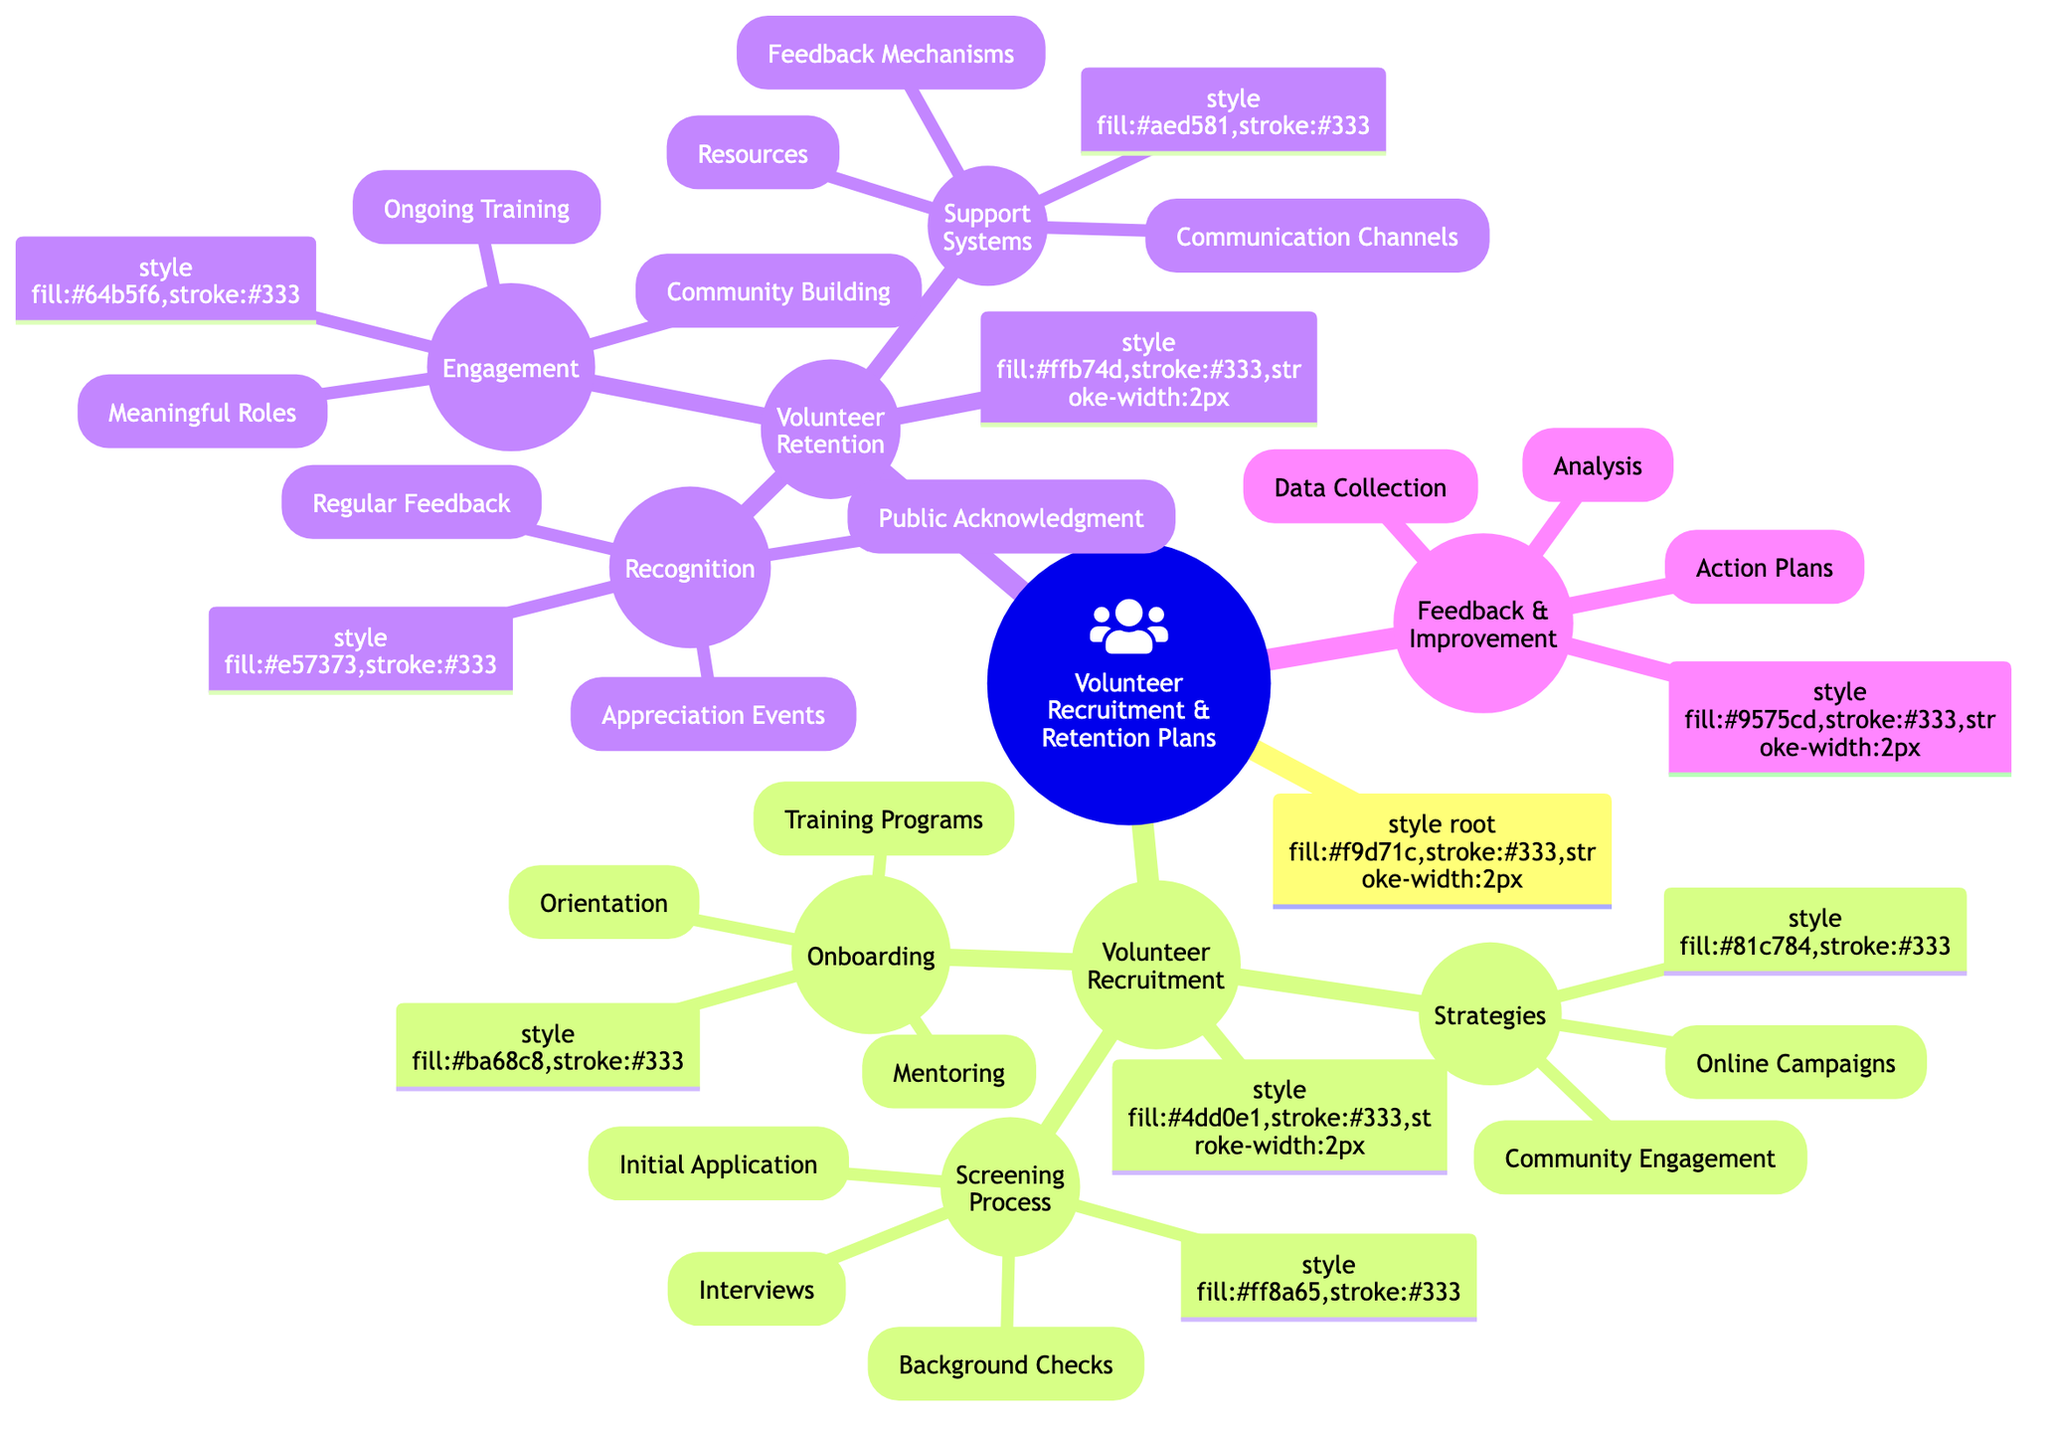What are the two main categories in the mind map? The mind map is organized into two primary sections: "Volunteer Recruitment" and "Volunteer Retention." These are the main categories that encompass all other subcategories within the diagram.
Answer: Volunteer Recruitment and Volunteer Retention How many strategies are listed under Volunteer Recruitment? Under the "Strategies" section of "Volunteer Recruitment," there are two distinct strategies: "Online Campaigns" and "Community Engagement." The total count of strategies is therefore two.
Answer: 2 What screening process follows 'Initial Application'? The next step in the screening process after "Initial Application," which includes "Online Form" and "Resume and Cover Letter," is "Interviews." This indicates the second layer of the screening process hierarchy.
Answer: Interviews Which retention component focuses on training and development? The component focused on training and development within "Volunteer Retention" is "Engagement," notably the "Ongoing Training" aspect that emphasizes workshops and leadership programs.
Answer: Engagement What is the relationship between "Feedback Mechanisms" and "Support Systems"? "Feedback Mechanisms" is a subcategory that falls under the "Support Systems" of "Volunteer Retention." This indicates that feedback mechanisms help form one of the essential systems to support volunteers.
Answer: Subcategory How many types of data collection methods are mentioned? Under "Feedback and Improvement," there are two data collection methods specified: "Volunteer Surveys" and "Exit Interviews," leading to a total of two methods.
Answer: 2 Which strategy includes "Local Events" and "School Partnerships"? The strategy that includes both "Local Events" and "School Partnerships" is categorized under "Community Engagement," which forms part of the overall "Volunteer Recruitment" strategies.
Answer: Community Engagement What do "Regular Feedback" and "Public Acknowledgment" have in common? Both "Regular Feedback" and "Public Acknowledgment" belong to the "Recognition" category under "Volunteer Retention." They both aim to appreciate and acknowledge volunteers for their contributions.
Answer: Recognition What is the main purpose of "Feedback and Improvement"? The purpose of "Feedback and Improvement" is to collect data regarding volunteers' experiences and to analyze this information to create actionable plans for enhancement, forming a continuous improvement cycle.
Answer: Continuous improvement 